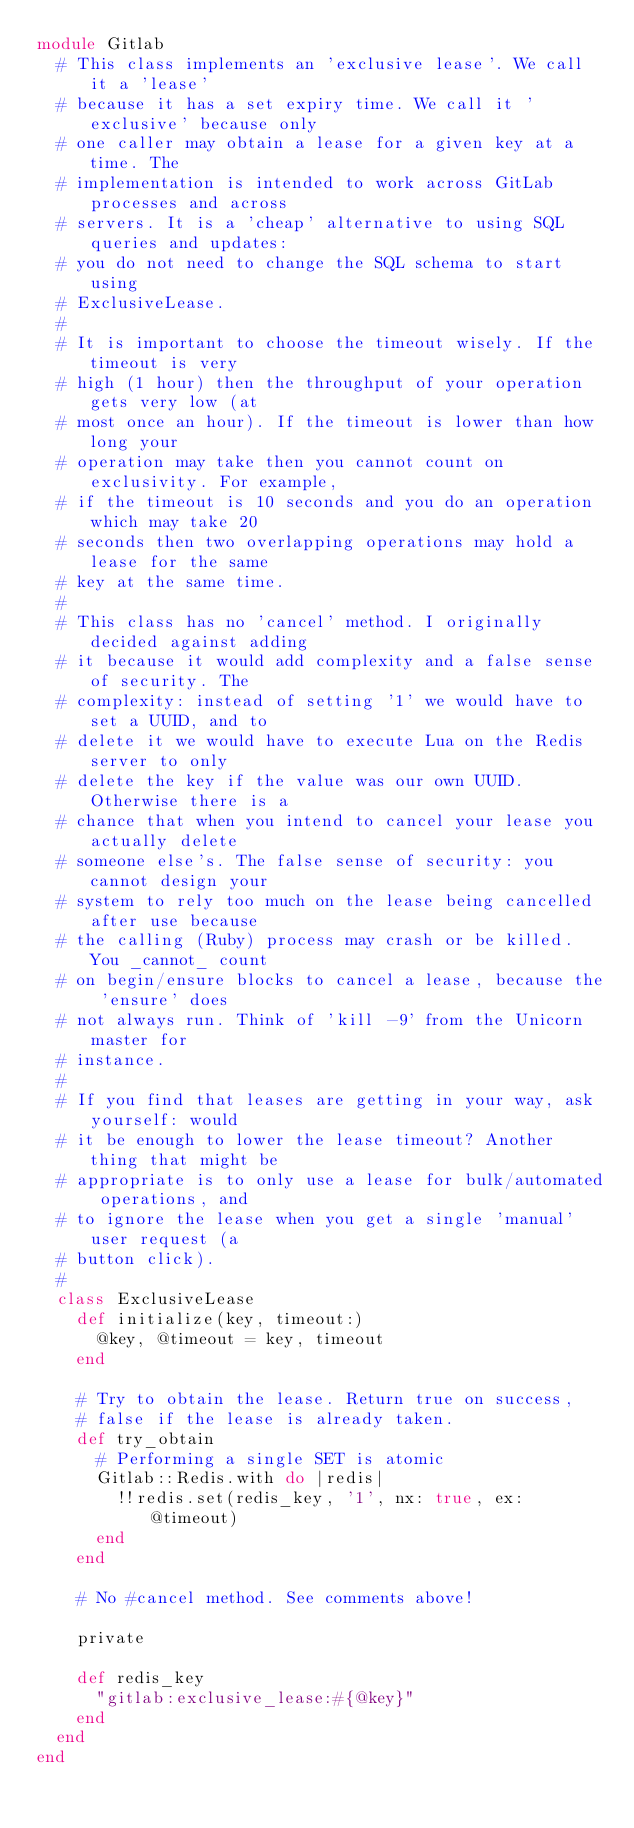Convert code to text. <code><loc_0><loc_0><loc_500><loc_500><_Ruby_>module Gitlab
  # This class implements an 'exclusive lease'. We call it a 'lease'
  # because it has a set expiry time. We call it 'exclusive' because only
  # one caller may obtain a lease for a given key at a time. The
  # implementation is intended to work across GitLab processes and across
  # servers. It is a 'cheap' alternative to using SQL queries and updates:
  # you do not need to change the SQL schema to start using
  # ExclusiveLease.
  #
  # It is important to choose the timeout wisely. If the timeout is very
  # high (1 hour) then the throughput of your operation gets very low (at
  # most once an hour). If the timeout is lower than how long your
  # operation may take then you cannot count on exclusivity. For example,
  # if the timeout is 10 seconds and you do an operation which may take 20
  # seconds then two overlapping operations may hold a lease for the same
  # key at the same time.
  #
  # This class has no 'cancel' method. I originally decided against adding
  # it because it would add complexity and a false sense of security. The
  # complexity: instead of setting '1' we would have to set a UUID, and to
  # delete it we would have to execute Lua on the Redis server to only
  # delete the key if the value was our own UUID. Otherwise there is a
  # chance that when you intend to cancel your lease you actually delete
  # someone else's. The false sense of security: you cannot design your
  # system to rely too much on the lease being cancelled after use because
  # the calling (Ruby) process may crash or be killed. You _cannot_ count
  # on begin/ensure blocks to cancel a lease, because the 'ensure' does
  # not always run. Think of 'kill -9' from the Unicorn master for
  # instance.
  # 
  # If you find that leases are getting in your way, ask yourself: would
  # it be enough to lower the lease timeout? Another thing that might be
  # appropriate is to only use a lease for bulk/automated operations, and
  # to ignore the lease when you get a single 'manual' user request (a
  # button click).
  #
  class ExclusiveLease
    def initialize(key, timeout:)
      @key, @timeout = key, timeout
    end

    # Try to obtain the lease. Return true on success,
    # false if the lease is already taken.
    def try_obtain
      # Performing a single SET is atomic
      Gitlab::Redis.with do |redis|
        !!redis.set(redis_key, '1', nx: true, ex: @timeout)
      end
    end

    # No #cancel method. See comments above!

    private

    def redis_key
      "gitlab:exclusive_lease:#{@key}"
    end
  end
end
</code> 